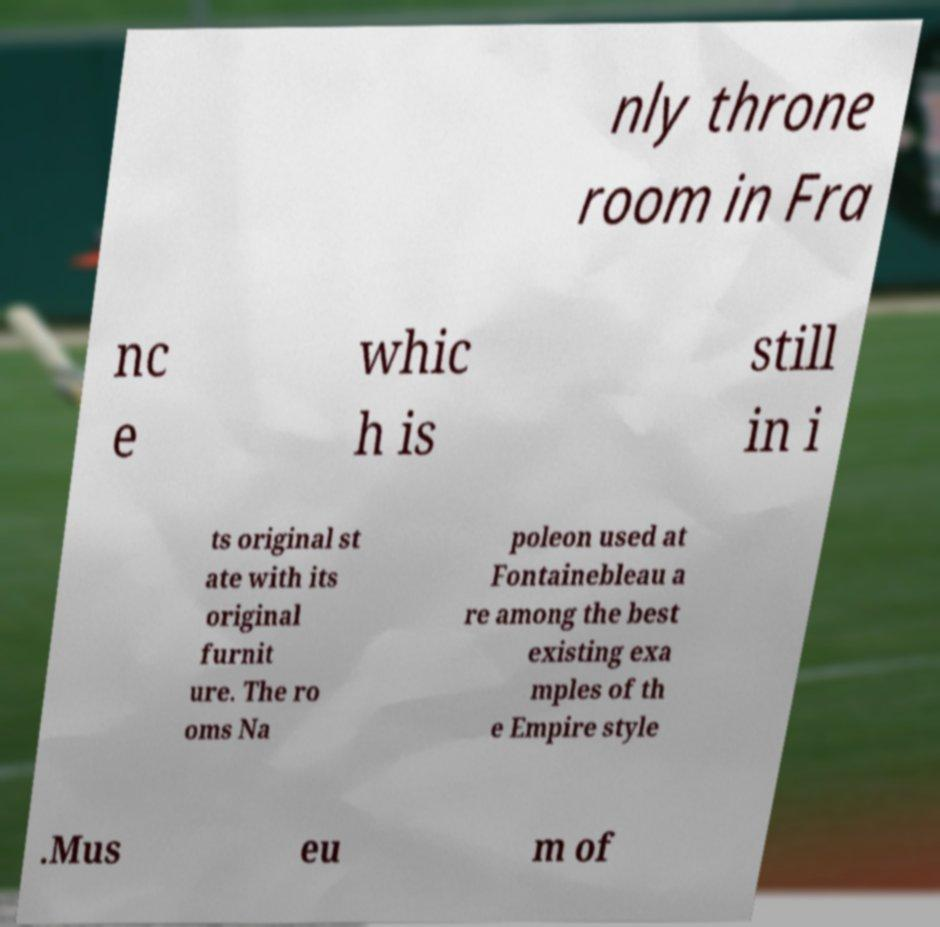There's text embedded in this image that I need extracted. Can you transcribe it verbatim? nly throne room in Fra nc e whic h is still in i ts original st ate with its original furnit ure. The ro oms Na poleon used at Fontainebleau a re among the best existing exa mples of th e Empire style .Mus eu m of 